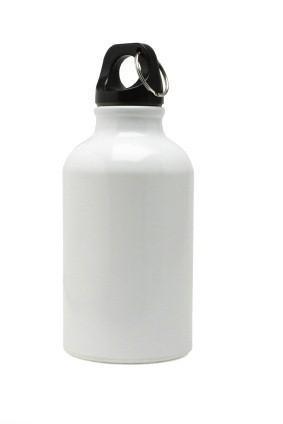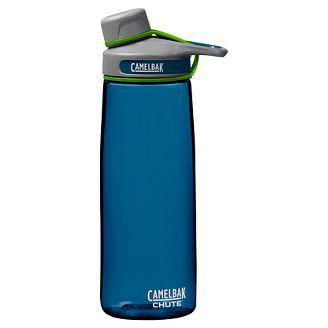The first image is the image on the left, the second image is the image on the right. Given the left and right images, does the statement "Out of the two bottles, one is blue." hold true? Answer yes or no. Yes. The first image is the image on the left, the second image is the image on the right. Examine the images to the left and right. Is the description "An image contains exactly one vivid purple upright water bottle." accurate? Answer yes or no. No. 